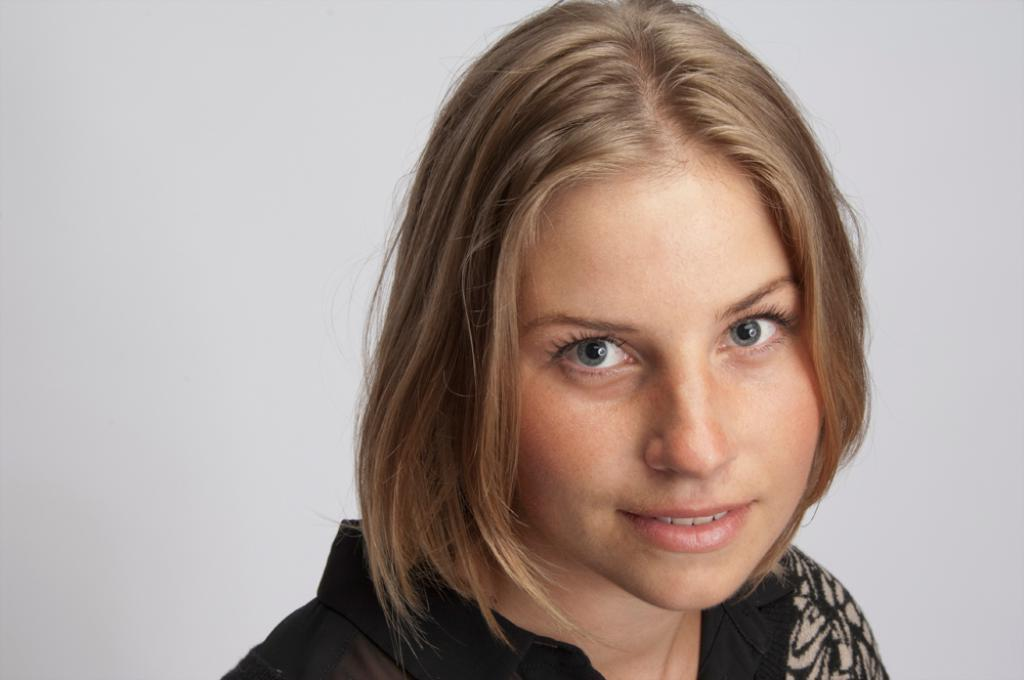What color is the dress the woman is wearing in the image? The woman is wearing a black dress in the image. What is the woman's facial expression in the image? The woman is smiling in the image. Is the woman looking at the camera in the image? Yes, the woman is looking at the camera in the image. What color is the background in the image? The background is white in color. Where is the woman's mom standing in the image? There is no information about the woman's mom in the image, so we cannot determine her position. How many cattle are visible in the image? There are no cattle present in the image. 